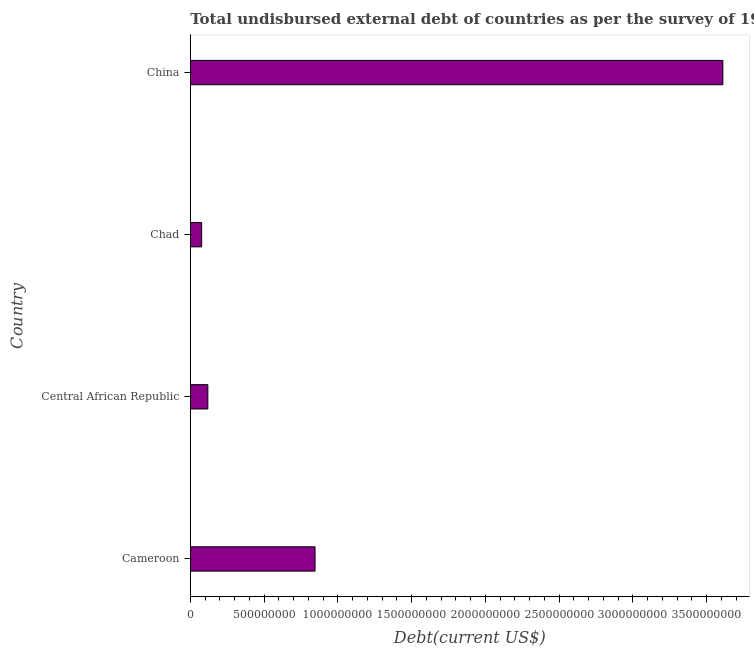Does the graph contain any zero values?
Ensure brevity in your answer.  No. What is the title of the graph?
Your answer should be very brief. Total undisbursed external debt of countries as per the survey of 1984. What is the label or title of the X-axis?
Offer a terse response. Debt(current US$). What is the label or title of the Y-axis?
Your answer should be very brief. Country. What is the total debt in Chad?
Provide a short and direct response. 7.70e+07. Across all countries, what is the maximum total debt?
Ensure brevity in your answer.  3.61e+09. Across all countries, what is the minimum total debt?
Your response must be concise. 7.70e+07. In which country was the total debt maximum?
Provide a succinct answer. China. In which country was the total debt minimum?
Your response must be concise. Chad. What is the sum of the total debt?
Give a very brief answer. 4.65e+09. What is the difference between the total debt in Central African Republic and China?
Offer a very short reply. -3.49e+09. What is the average total debt per country?
Offer a very short reply. 1.16e+09. What is the median total debt?
Keep it short and to the point. 4.82e+08. What is the ratio of the total debt in Chad to that in China?
Your answer should be very brief. 0.02. Is the difference between the total debt in Chad and China greater than the difference between any two countries?
Make the answer very short. Yes. What is the difference between the highest and the second highest total debt?
Offer a very short reply. 2.76e+09. Is the sum of the total debt in Cameroon and Chad greater than the maximum total debt across all countries?
Ensure brevity in your answer.  No. What is the difference between the highest and the lowest total debt?
Your answer should be compact. 3.53e+09. In how many countries, is the total debt greater than the average total debt taken over all countries?
Your answer should be compact. 1. How many bars are there?
Offer a very short reply. 4. Are all the bars in the graph horizontal?
Offer a very short reply. Yes. What is the Debt(current US$) of Cameroon?
Give a very brief answer. 8.46e+08. What is the Debt(current US$) of Central African Republic?
Provide a succinct answer. 1.19e+08. What is the Debt(current US$) of Chad?
Keep it short and to the point. 7.70e+07. What is the Debt(current US$) of China?
Ensure brevity in your answer.  3.61e+09. What is the difference between the Debt(current US$) in Cameroon and Central African Republic?
Ensure brevity in your answer.  7.27e+08. What is the difference between the Debt(current US$) in Cameroon and Chad?
Your response must be concise. 7.69e+08. What is the difference between the Debt(current US$) in Cameroon and China?
Your answer should be compact. -2.76e+09. What is the difference between the Debt(current US$) in Central African Republic and Chad?
Offer a terse response. 4.20e+07. What is the difference between the Debt(current US$) in Central African Republic and China?
Keep it short and to the point. -3.49e+09. What is the difference between the Debt(current US$) in Chad and China?
Give a very brief answer. -3.53e+09. What is the ratio of the Debt(current US$) in Cameroon to that in Central African Republic?
Your answer should be compact. 7.11. What is the ratio of the Debt(current US$) in Cameroon to that in Chad?
Offer a very short reply. 10.98. What is the ratio of the Debt(current US$) in Cameroon to that in China?
Your answer should be compact. 0.23. What is the ratio of the Debt(current US$) in Central African Republic to that in Chad?
Give a very brief answer. 1.55. What is the ratio of the Debt(current US$) in Central African Republic to that in China?
Your response must be concise. 0.03. What is the ratio of the Debt(current US$) in Chad to that in China?
Ensure brevity in your answer.  0.02. 